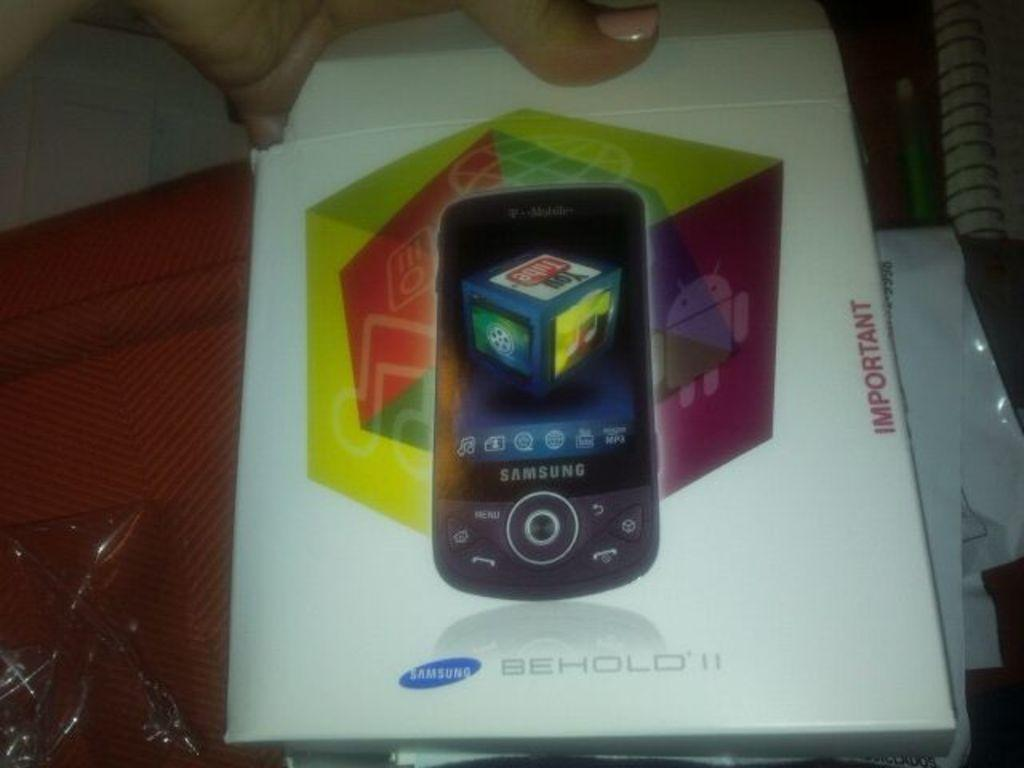<image>
Share a concise interpretation of the image provided. A Samsung brand phone is called Behold 11. 